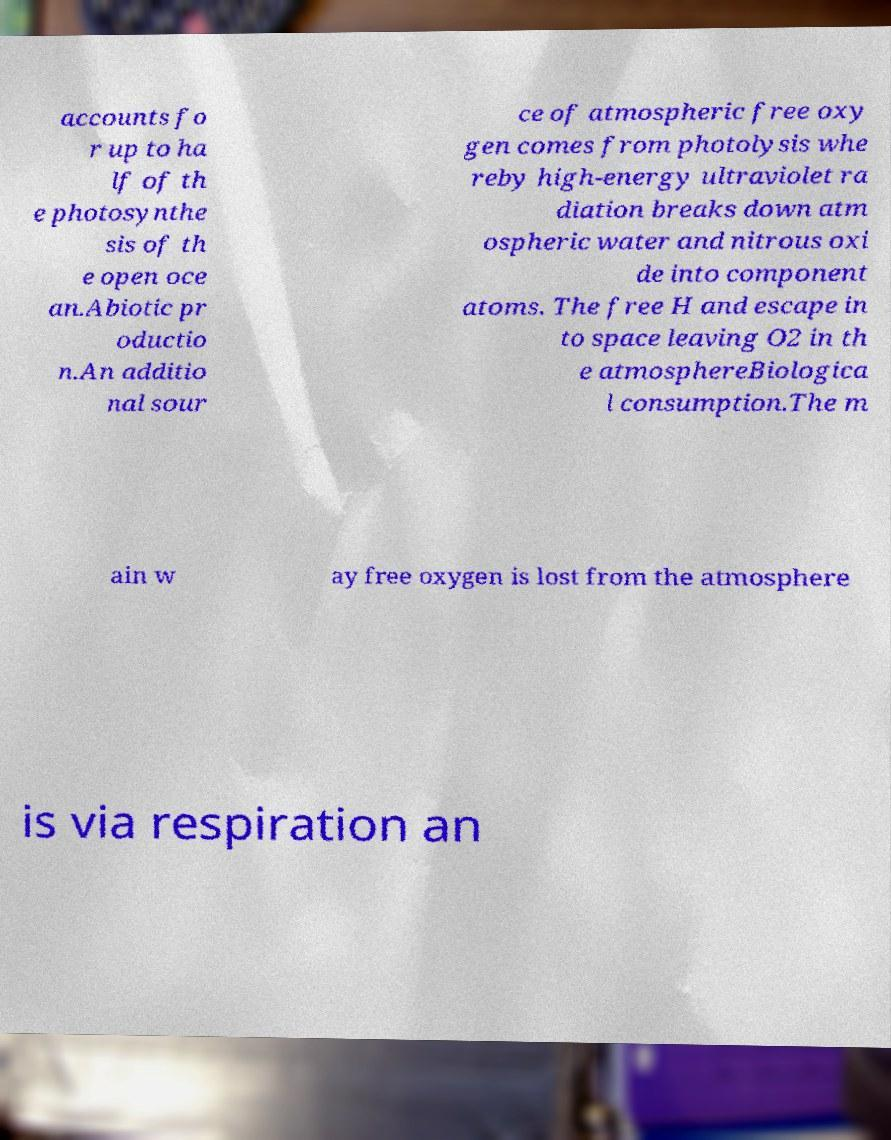Please read and relay the text visible in this image. What does it say? accounts fo r up to ha lf of th e photosynthe sis of th e open oce an.Abiotic pr oductio n.An additio nal sour ce of atmospheric free oxy gen comes from photolysis whe reby high-energy ultraviolet ra diation breaks down atm ospheric water and nitrous oxi de into component atoms. The free H and escape in to space leaving O2 in th e atmosphereBiologica l consumption.The m ain w ay free oxygen is lost from the atmosphere is via respiration an 